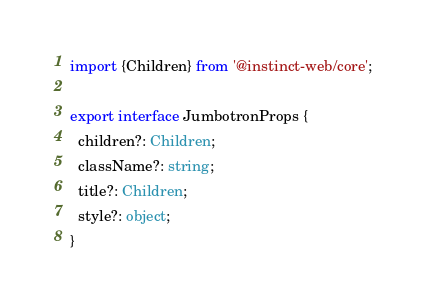<code> <loc_0><loc_0><loc_500><loc_500><_TypeScript_>import {Children} from '@instinct-web/core';

export interface JumbotronProps {
  children?: Children;
  className?: string;
  title?: Children;
  style?: object;
}
</code> 